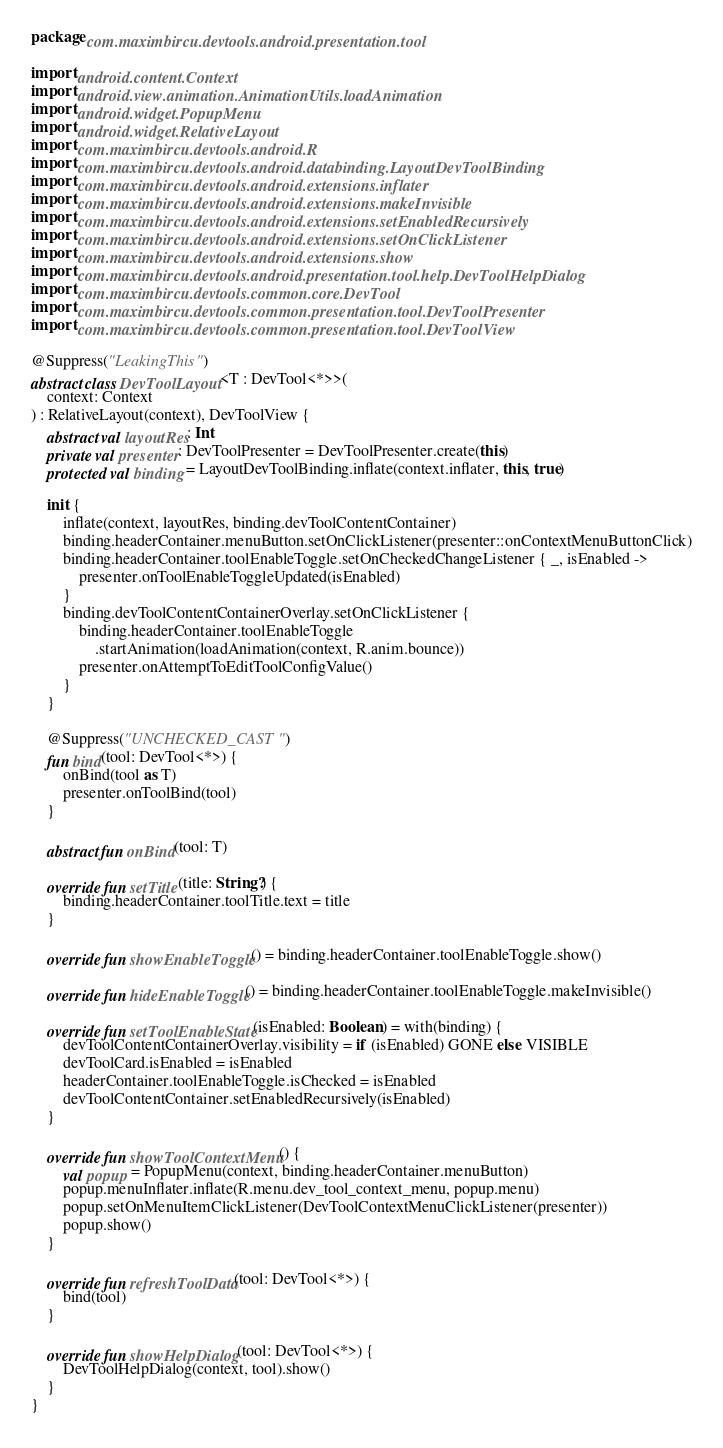<code> <loc_0><loc_0><loc_500><loc_500><_Kotlin_>package com.maximbircu.devtools.android.presentation.tool

import android.content.Context
import android.view.animation.AnimationUtils.loadAnimation
import android.widget.PopupMenu
import android.widget.RelativeLayout
import com.maximbircu.devtools.android.R
import com.maximbircu.devtools.android.databinding.LayoutDevToolBinding
import com.maximbircu.devtools.android.extensions.inflater
import com.maximbircu.devtools.android.extensions.makeInvisible
import com.maximbircu.devtools.android.extensions.setEnabledRecursively
import com.maximbircu.devtools.android.extensions.setOnClickListener
import com.maximbircu.devtools.android.extensions.show
import com.maximbircu.devtools.android.presentation.tool.help.DevToolHelpDialog
import com.maximbircu.devtools.common.core.DevTool
import com.maximbircu.devtools.common.presentation.tool.DevToolPresenter
import com.maximbircu.devtools.common.presentation.tool.DevToolView

@Suppress("LeakingThis")
abstract class DevToolLayout<T : DevTool<*>>(
    context: Context
) : RelativeLayout(context), DevToolView {
    abstract val layoutRes: Int
    private val presenter: DevToolPresenter = DevToolPresenter.create(this)
    protected val binding = LayoutDevToolBinding.inflate(context.inflater, this, true)

    init {
        inflate(context, layoutRes, binding.devToolContentContainer)
        binding.headerContainer.menuButton.setOnClickListener(presenter::onContextMenuButtonClick)
        binding.headerContainer.toolEnableToggle.setOnCheckedChangeListener { _, isEnabled ->
            presenter.onToolEnableToggleUpdated(isEnabled)
        }
        binding.devToolContentContainerOverlay.setOnClickListener {
            binding.headerContainer.toolEnableToggle
                .startAnimation(loadAnimation(context, R.anim.bounce))
            presenter.onAttemptToEditToolConfigValue()
        }
    }

    @Suppress("UNCHECKED_CAST")
    fun bind(tool: DevTool<*>) {
        onBind(tool as T)
        presenter.onToolBind(tool)
    }

    abstract fun onBind(tool: T)

    override fun setTitle(title: String?) {
        binding.headerContainer.toolTitle.text = title
    }

    override fun showEnableToggle() = binding.headerContainer.toolEnableToggle.show()

    override fun hideEnableToggle() = binding.headerContainer.toolEnableToggle.makeInvisible()

    override fun setToolEnableState(isEnabled: Boolean) = with(binding) {
        devToolContentContainerOverlay.visibility = if (isEnabled) GONE else VISIBLE
        devToolCard.isEnabled = isEnabled
        headerContainer.toolEnableToggle.isChecked = isEnabled
        devToolContentContainer.setEnabledRecursively(isEnabled)
    }

    override fun showToolContextMenu() {
        val popup = PopupMenu(context, binding.headerContainer.menuButton)
        popup.menuInflater.inflate(R.menu.dev_tool_context_menu, popup.menu)
        popup.setOnMenuItemClickListener(DevToolContextMenuClickListener(presenter))
        popup.show()
    }

    override fun refreshToolData(tool: DevTool<*>) {
        bind(tool)
    }

    override fun showHelpDialog(tool: DevTool<*>) {
        DevToolHelpDialog(context, tool).show()
    }
}
</code> 